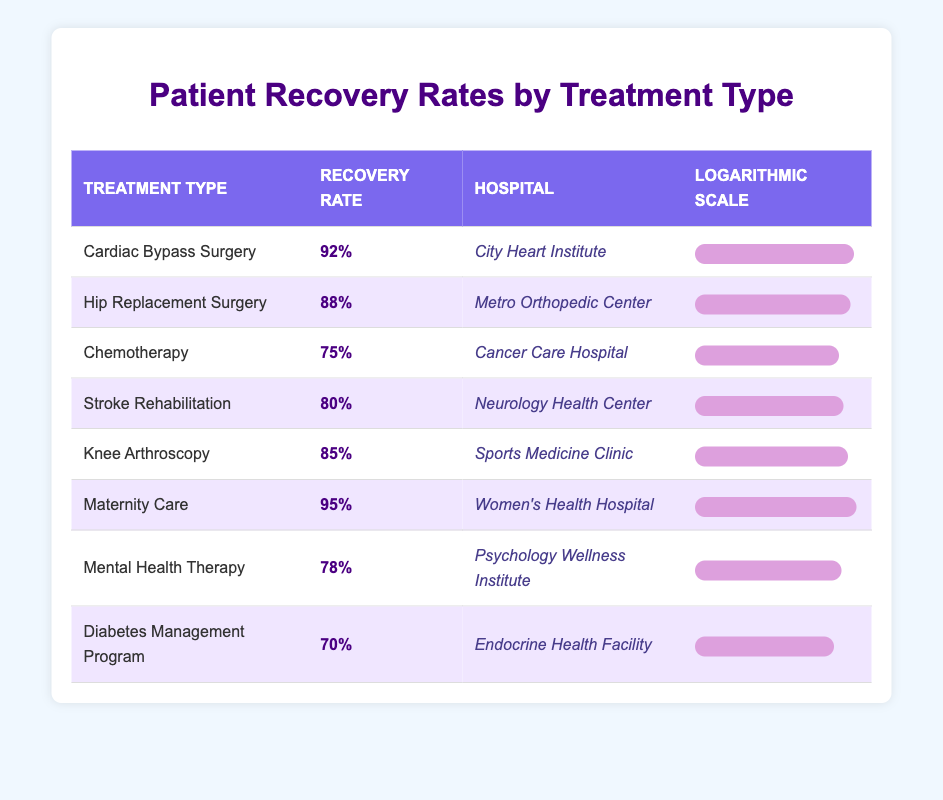What is the recovery rate for Knee Arthroscopy? The table lists the recovery rate for Knee Arthroscopy under the "Recovery Rate" column. The value indicated there is 85%.
Answer: 85% Which hospital specializes in Maternity Care? The table shows that Women's Health Hospital is the hospital associated with Maternity Care.
Answer: Women's Health Hospital Is the recovery rate for Chemotherapy higher than for Diabetes Management Program? The recovery rate for Chemotherapy is 75% and for Diabetes Management Program is 70%. Since 75% is greater than 70%, the statement is true.
Answer: Yes What is the average recovery rate for the treatments listed? To find the average, sum the recovery rates: 92 + 88 + 75 + 80 + 85 + 95 + 78 + 70 = 693. There are 8 treatments, so the average is 693 / 8 = 86.625, which rounds to 86.63%.
Answer: 86.63% Which treatment type has the highest recovery rate? The highest recovery rate is for Maternity Care, which is 95%. This value is the highest compared to all other treatment types in the table.
Answer: Maternity Care How does the recovery rate for Hip Replacement Surgery compare to Stroke Rehabilitation? The recovery rate for Hip Replacement Surgery is 88% and for Stroke Rehabilitation is 80%. Since 88% is greater than 80%, Hip Replacement Surgery has a higher recovery rate.
Answer: Hip Replacement Surgery has a higher recovery rate Are there more treatment types with recovery rates above 80% or below 80%? By examining the table, we see that treatment types with recovery rates above 80% are: Cardiac Bypass Surgery (92%), Hip Replacement Surgery (88%), Stroke Rehabilitation (80%), Knee Arthroscopy (85%), Maternity Care (95%), and Mental Health Therapy (78%). This totals 5 treatments above 80% and only 2 (Chemotherapy and Diabetes Management Program) below 80%. Thus, there are more treatments above 80%.
Answer: More above 80% Which treatment type has the lowest recovery rate? By inspecting the table, the treatment with the lowest recovery rate is Diabetes Management Program, which has a rate of 70%.
Answer: Diabetes Management Program 